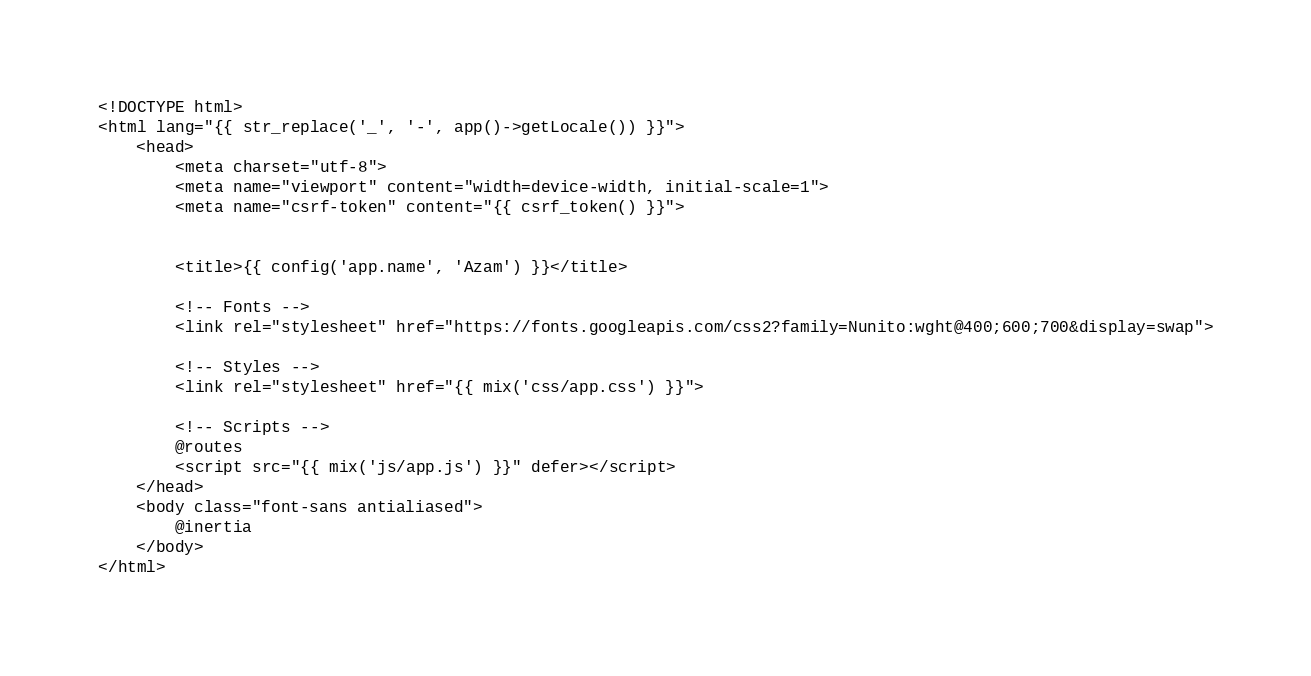Convert code to text. <code><loc_0><loc_0><loc_500><loc_500><_PHP_><!DOCTYPE html>
<html lang="{{ str_replace('_', '-', app()->getLocale()) }}">
    <head>
        <meta charset="utf-8">
        <meta name="viewport" content="width=device-width, initial-scale=1">
        <meta name="csrf-token" content="{{ csrf_token() }}">


        <title>{{ config('app.name', 'Azam') }}</title>

        <!-- Fonts -->
        <link rel="stylesheet" href="https://fonts.googleapis.com/css2?family=Nunito:wght@400;600;700&display=swap">

        <!-- Styles -->
        <link rel="stylesheet" href="{{ mix('css/app.css') }}">

        <!-- Scripts -->
        @routes
        <script src="{{ mix('js/app.js') }}" defer></script>
    </head>
    <body class="font-sans antialiased">
        @inertia
    </body>
</html>
</code> 